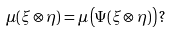Convert formula to latex. <formula><loc_0><loc_0><loc_500><loc_500>\mu ( \xi \otimes \eta ) = \mu \left ( \Psi ( \xi \otimes \eta ) \right ) \, ?</formula> 